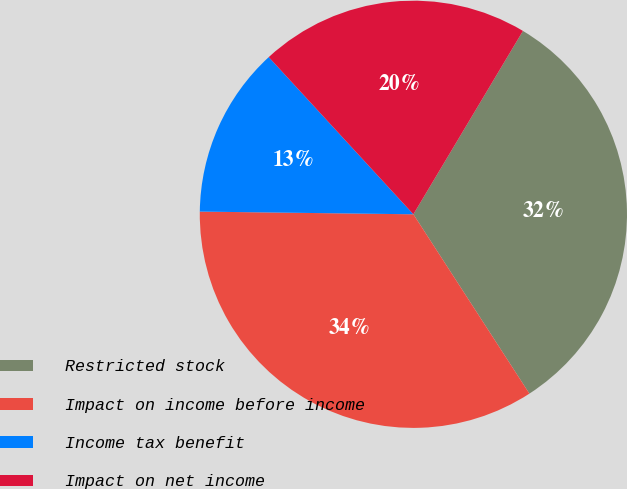Convert chart to OTSL. <chart><loc_0><loc_0><loc_500><loc_500><pie_chart><fcel>Restricted stock<fcel>Impact on income before income<fcel>Income tax benefit<fcel>Impact on net income<nl><fcel>32.29%<fcel>34.34%<fcel>12.96%<fcel>20.41%<nl></chart> 